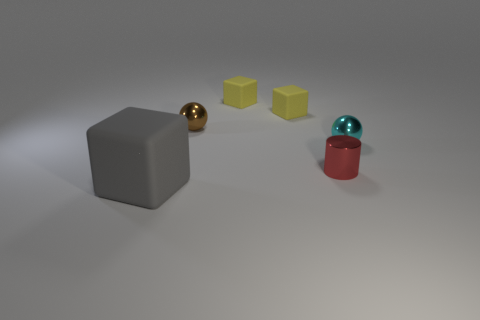Are there more tiny brown things than metal balls?
Offer a very short reply. No. What size is the metallic ball in front of the ball to the left of the tiny metal cylinder?
Provide a succinct answer. Small. What shape is the cyan shiny object that is the same size as the red thing?
Make the answer very short. Sphere. There is a matte object left of the shiny sphere that is to the left of the shiny ball on the right side of the tiny red thing; what is its shape?
Provide a short and direct response. Cube. What number of tiny brown metallic objects are there?
Your answer should be compact. 1. Are there any yellow rubber things on the right side of the brown shiny ball?
Your answer should be compact. Yes. Are the cube in front of the brown sphere and the sphere in front of the brown metal sphere made of the same material?
Keep it short and to the point. No. Are there fewer small cubes that are to the left of the big gray object than blue things?
Ensure brevity in your answer.  No. What color is the block in front of the cyan shiny ball?
Provide a short and direct response. Gray. There is a gray cube that is to the left of the small metal thing right of the metallic cylinder; what is it made of?
Ensure brevity in your answer.  Rubber. 